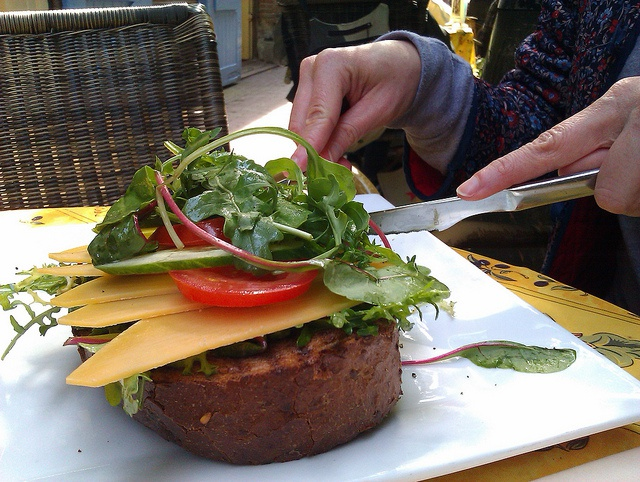Describe the objects in this image and their specific colors. I can see sandwich in olive, maroon, black, darkgreen, and tan tones, people in olive, black, brown, and maroon tones, chair in olive, black, and gray tones, and knife in olive, darkgray, gray, and lightgray tones in this image. 